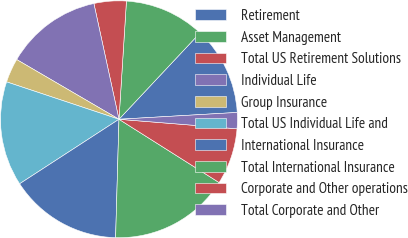Convert chart. <chart><loc_0><loc_0><loc_500><loc_500><pie_chart><fcel>Retirement<fcel>Asset Management<fcel>Total US Retirement Solutions<fcel>Individual Life<fcel>Group Insurance<fcel>Total US Individual Life and<fcel>International Insurance<fcel>Total International Insurance<fcel>Corporate and Other operations<fcel>Total Corporate and Other<nl><fcel>12.09%<fcel>10.99%<fcel>4.4%<fcel>13.19%<fcel>3.3%<fcel>14.28%<fcel>15.38%<fcel>16.48%<fcel>7.69%<fcel>2.2%<nl></chart> 